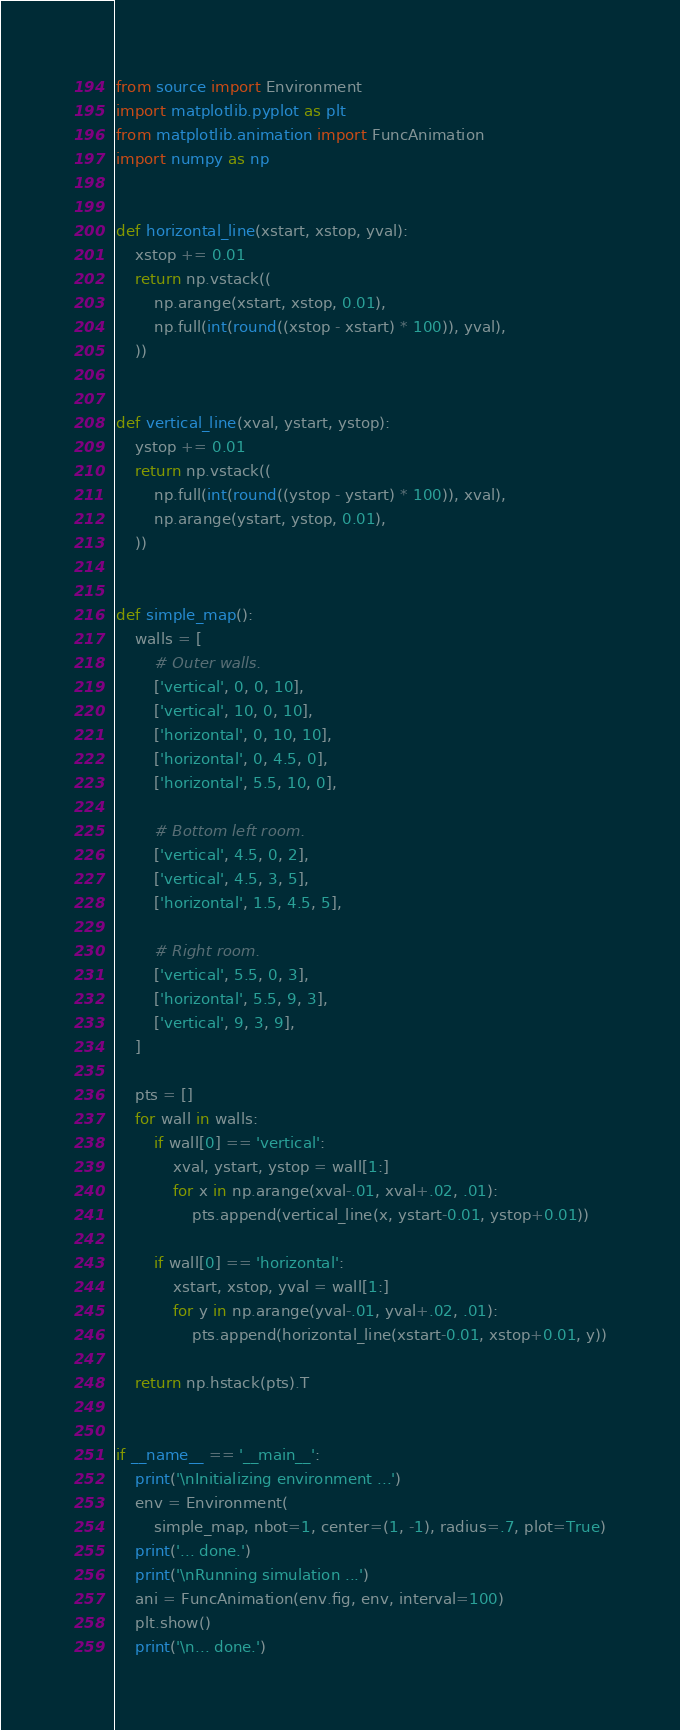<code> <loc_0><loc_0><loc_500><loc_500><_Python_>from source import Environment
import matplotlib.pyplot as plt
from matplotlib.animation import FuncAnimation
import numpy as np


def horizontal_line(xstart, xstop, yval):
    xstop += 0.01
    return np.vstack((
        np.arange(xstart, xstop, 0.01),
        np.full(int(round((xstop - xstart) * 100)), yval),
    ))


def vertical_line(xval, ystart, ystop):
    ystop += 0.01
    return np.vstack((
        np.full(int(round((ystop - ystart) * 100)), xval),
        np.arange(ystart, ystop, 0.01),
    ))


def simple_map():
    walls = [
        # Outer walls.
        ['vertical', 0, 0, 10],
        ['vertical', 10, 0, 10],
        ['horizontal', 0, 10, 10],
        ['horizontal', 0, 4.5, 0],
        ['horizontal', 5.5, 10, 0],

        # Bottom left room.
        ['vertical', 4.5, 0, 2],
        ['vertical', 4.5, 3, 5],
        ['horizontal', 1.5, 4.5, 5],

        # Right room.
        ['vertical', 5.5, 0, 3],
        ['horizontal', 5.5, 9, 3],
        ['vertical', 9, 3, 9],
    ]

    pts = []
    for wall in walls:
        if wall[0] == 'vertical':
            xval, ystart, ystop = wall[1:]
            for x in np.arange(xval-.01, xval+.02, .01):
                pts.append(vertical_line(x, ystart-0.01, ystop+0.01))

        if wall[0] == 'horizontal':
            xstart, xstop, yval = wall[1:]
            for y in np.arange(yval-.01, yval+.02, .01):
                pts.append(horizontal_line(xstart-0.01, xstop+0.01, y))

    return np.hstack(pts).T


if __name__ == '__main__':
    print('\nInitializing environment ...')
    env = Environment(
        simple_map, nbot=1, center=(1, -1), radius=.7, plot=True)
    print('... done.')
    print('\nRunning simulation ...')
    ani = FuncAnimation(env.fig, env, interval=100)
    plt.show()
    print('\n... done.')
</code> 